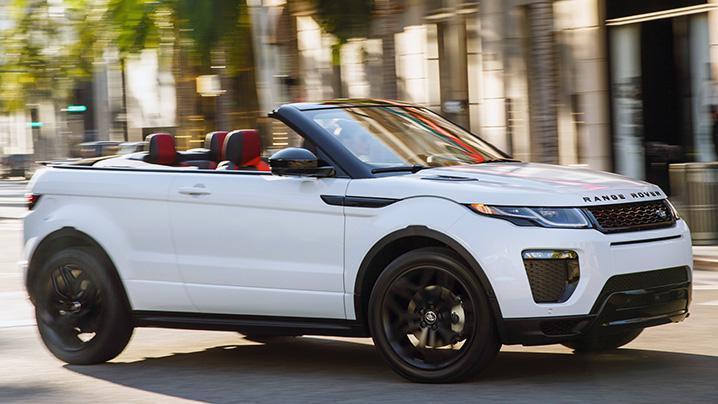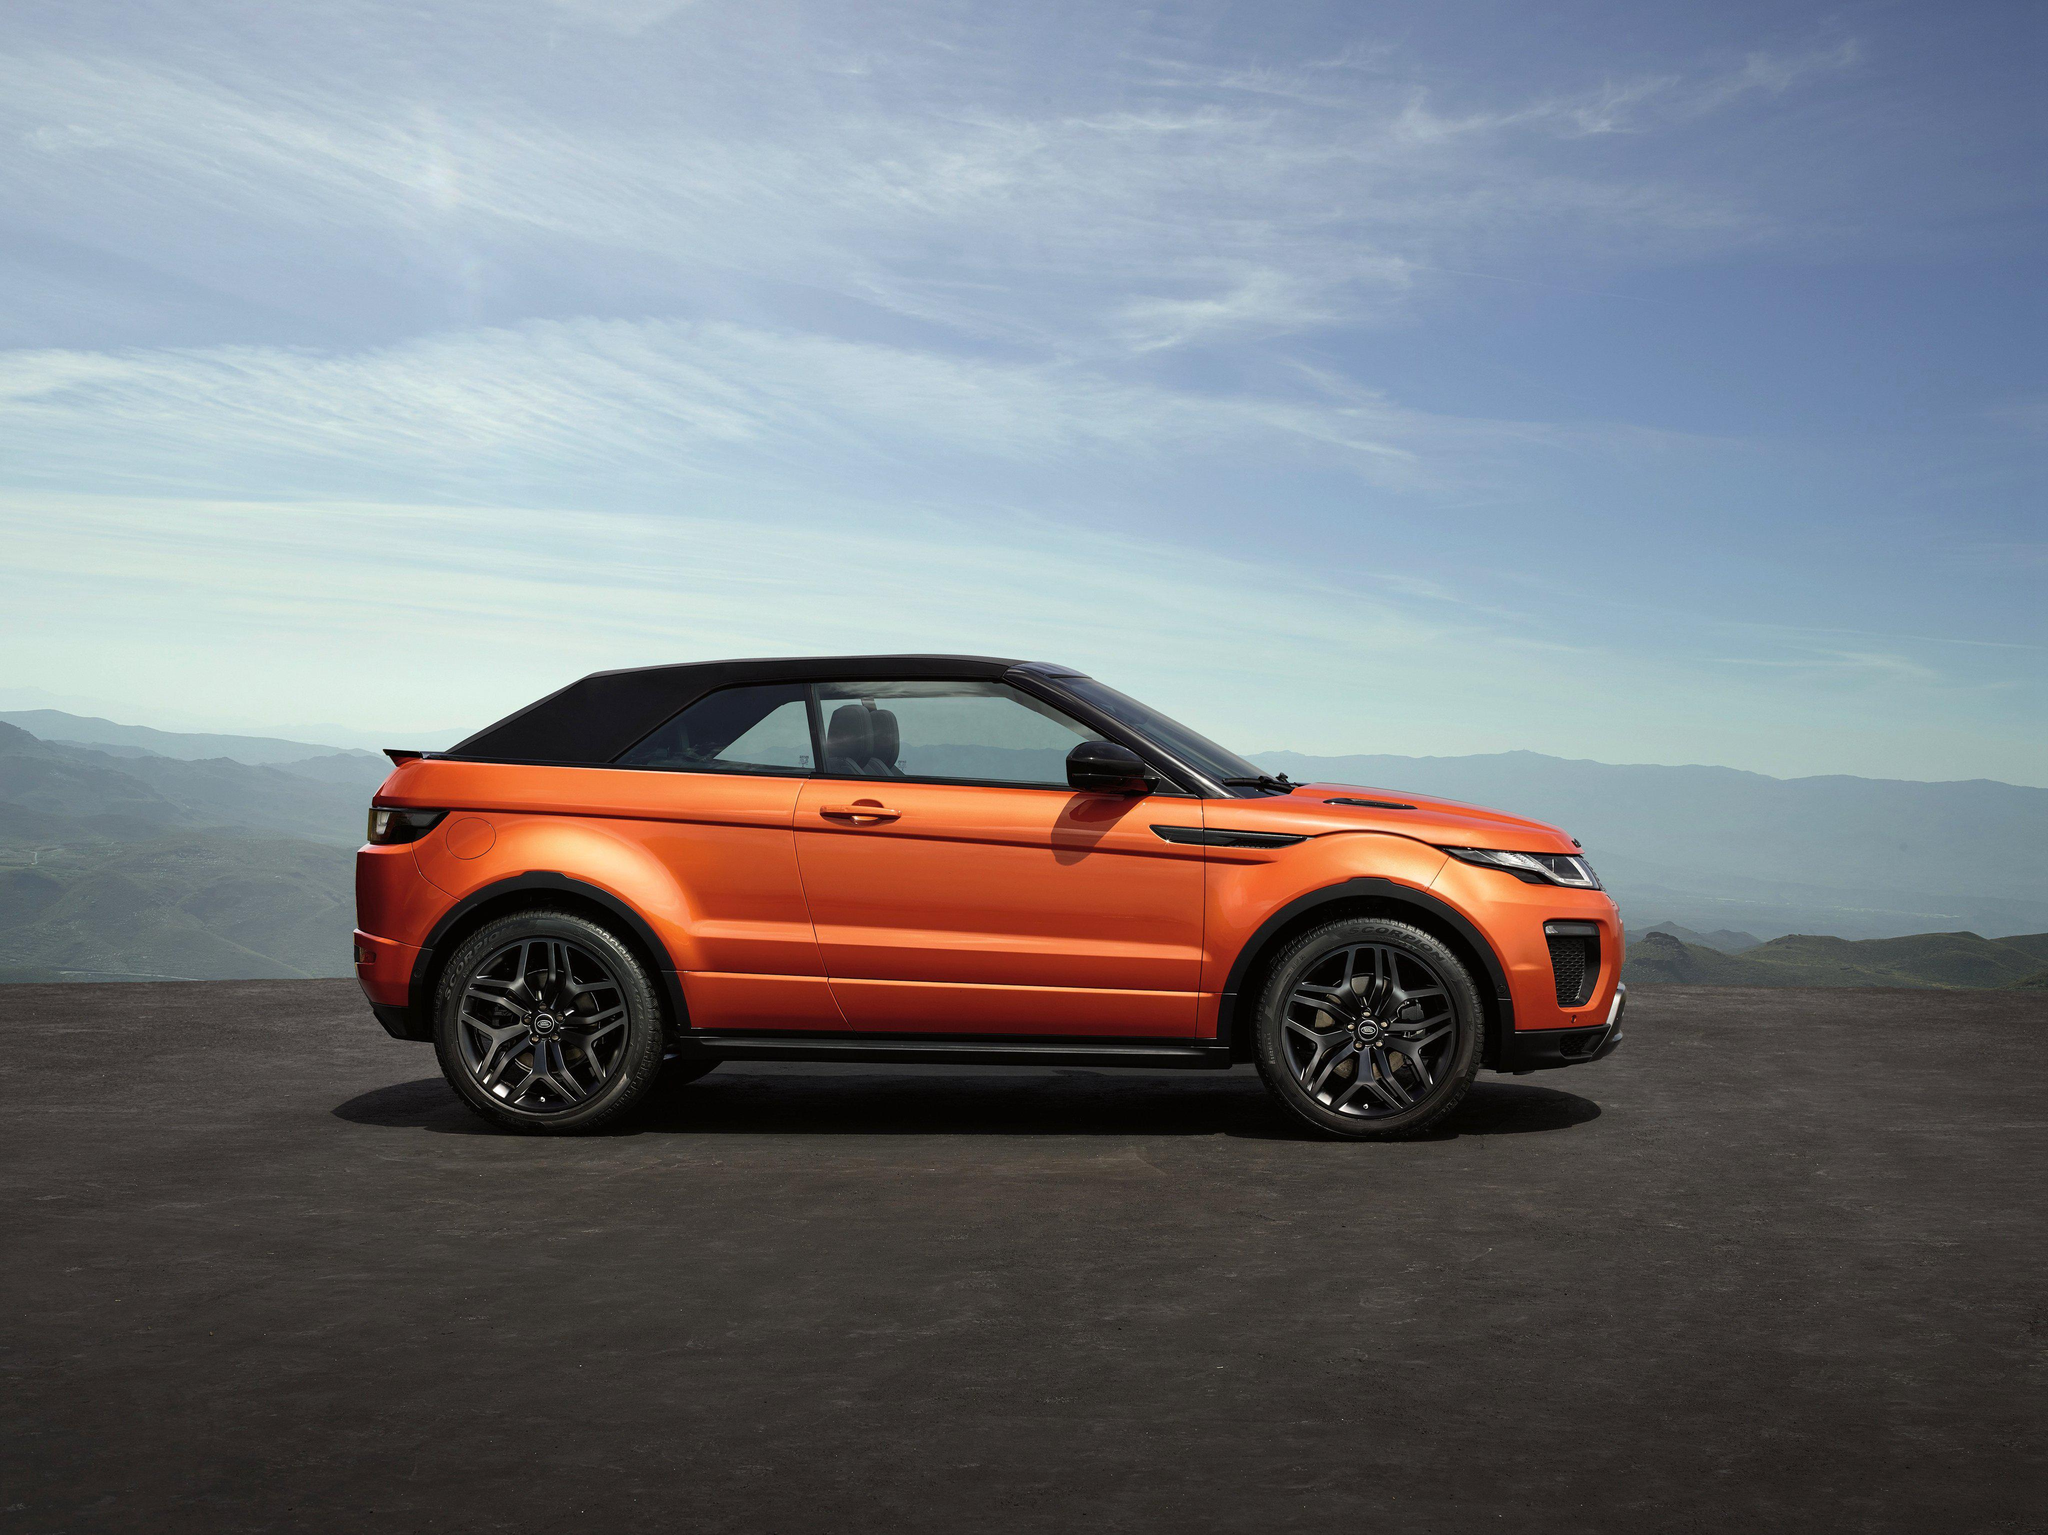The first image is the image on the left, the second image is the image on the right. Considering the images on both sides, is "There is one orange convertible with the top down and one white convertible with the top down" valid? Answer yes or no. No. The first image is the image on the left, the second image is the image on the right. Considering the images on both sides, is "An image shows an orange convertible, which has its top down." valid? Answer yes or no. No. 